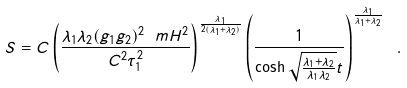Convert formula to latex. <formula><loc_0><loc_0><loc_500><loc_500>\ S = C \left ( \frac { \lambda _ { 1 } \lambda _ { 2 } ( g _ { 1 } g _ { 2 } ) ^ { 2 } \ m H ^ { 2 } } { C ^ { 2 } \tau _ { 1 } ^ { 2 } } \right ) ^ { \frac { \lambda _ { 1 } } { 2 ( \lambda _ { 1 } + \lambda _ { 2 } ) } } \left ( \frac { 1 } { \cosh \sqrt { \frac { \lambda _ { 1 } + \lambda _ { 2 } } { \lambda _ { 1 } \lambda _ { 2 } } } t } \right ) ^ { \frac { \lambda _ { 1 } } { \lambda _ { 1 } + \lambda _ { 2 } } } \ .</formula> 